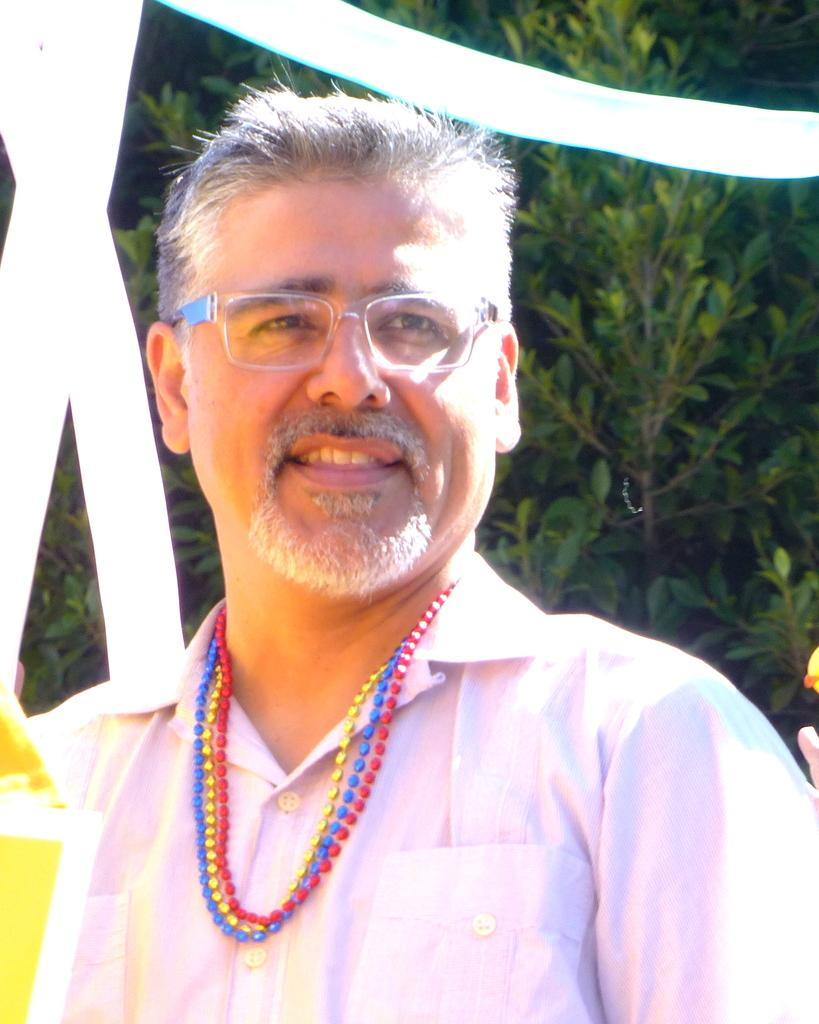What is the main subject of the image? There is a person in the image. What is the person wearing on their upper body? The person is wearing a pink shirt. What accessory is the person wearing on their face? The person is wearing spectacles. What type of jewelry is the person wearing around their neck? There are red, yellow, and blue color chains around the person's neck. What can be seen in the background of the image? There are trees in the background of the image. Can you tell me how many airplanes are visible in the image? There are no airplanes visible in the image; it features a person with a pink shirt, spectacles, and colorful chains around their neck, with trees in the background. What type of debt is the person in the image dealing with? There is no indication of debt or any financial situation in the image; it focuses on the person's appearance and the background. 